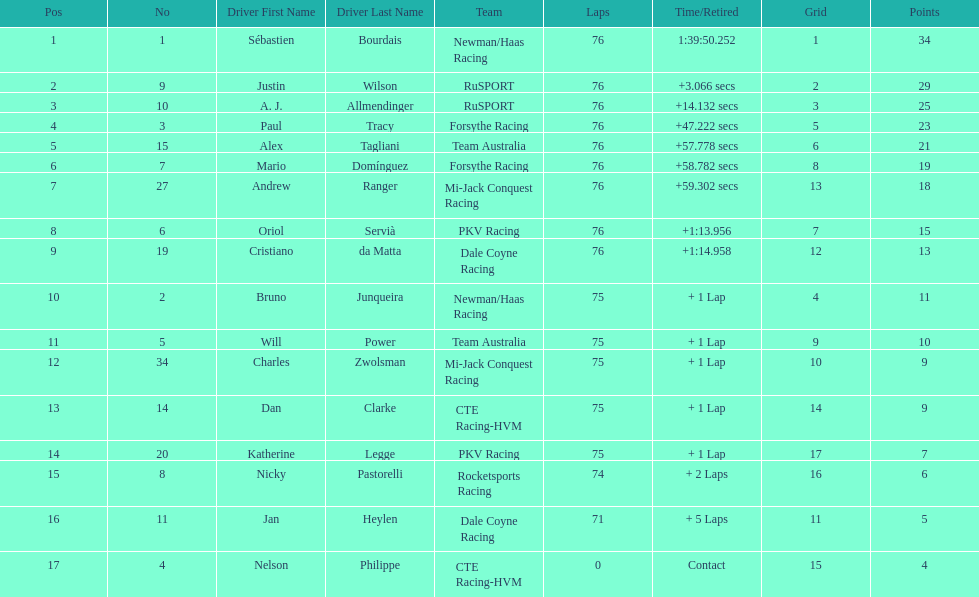What is the total point difference between the driver who received the most points and the driver who received the least? 30. 